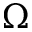<formula> <loc_0><loc_0><loc_500><loc_500>\Omega</formula> 